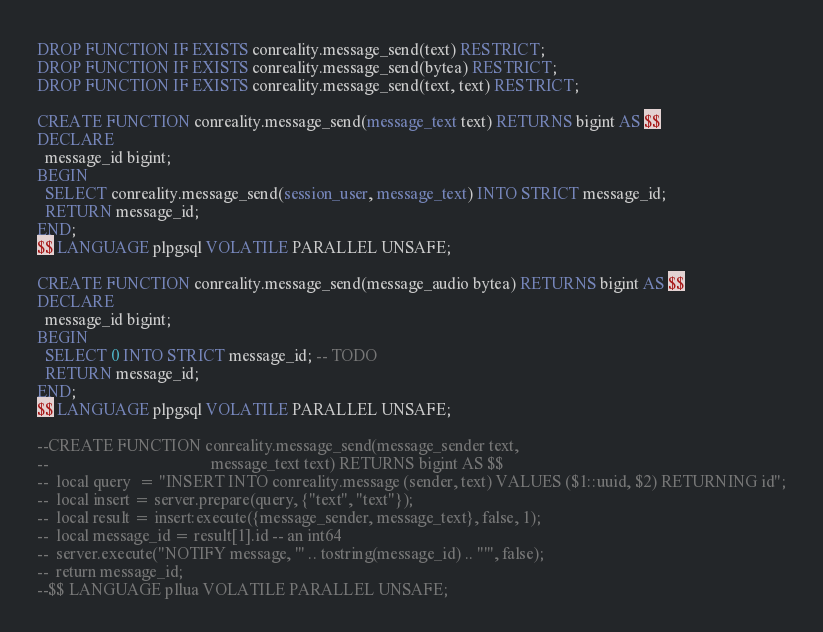Convert code to text. <code><loc_0><loc_0><loc_500><loc_500><_SQL_>DROP FUNCTION IF EXISTS conreality.message_send(text) RESTRICT;
DROP FUNCTION IF EXISTS conreality.message_send(bytea) RESTRICT;
DROP FUNCTION IF EXISTS conreality.message_send(text, text) RESTRICT;

CREATE FUNCTION conreality.message_send(message_text text) RETURNS bigint AS $$
DECLARE
  message_id bigint;
BEGIN
  SELECT conreality.message_send(session_user, message_text) INTO STRICT message_id;
  RETURN message_id;
END;
$$ LANGUAGE plpgsql VOLATILE PARALLEL UNSAFE;

CREATE FUNCTION conreality.message_send(message_audio bytea) RETURNS bigint AS $$
DECLARE
  message_id bigint;
BEGIN
  SELECT 0 INTO STRICT message_id; -- TODO
  RETURN message_id;
END;
$$ LANGUAGE plpgsql VOLATILE PARALLEL UNSAFE;

--CREATE FUNCTION conreality.message_send(message_sender text,
--                                        message_text text) RETURNS bigint AS $$
--  local query  = "INSERT INTO conreality.message (sender, text) VALUES ($1::uuid, $2) RETURNING id";
--  local insert = server.prepare(query, {"text", "text"});
--  local result = insert:execute({message_sender, message_text}, false, 1);
--  local message_id = result[1].id -- an int64
--  server.execute("NOTIFY message, '" .. tostring(message_id) .. "'", false);
--  return message_id;
--$$ LANGUAGE pllua VOLATILE PARALLEL UNSAFE;
</code> 